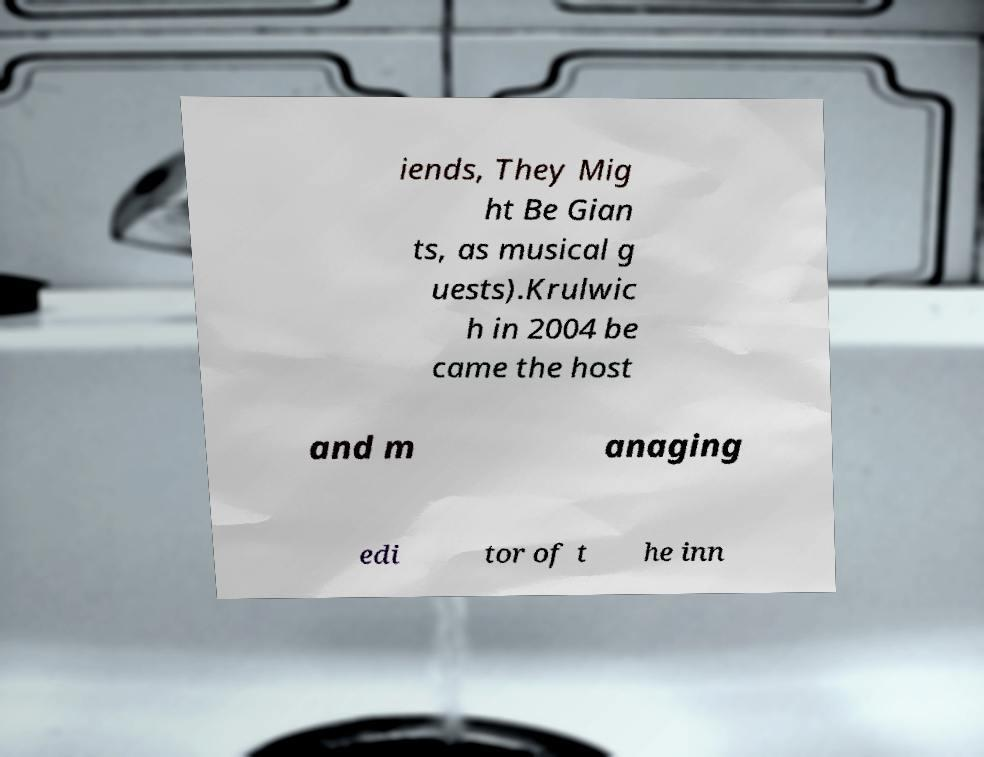There's text embedded in this image that I need extracted. Can you transcribe it verbatim? iends, They Mig ht Be Gian ts, as musical g uests).Krulwic h in 2004 be came the host and m anaging edi tor of t he inn 